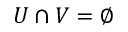<formula> <loc_0><loc_0><loc_500><loc_500>U \cap V = \emptyset</formula> 